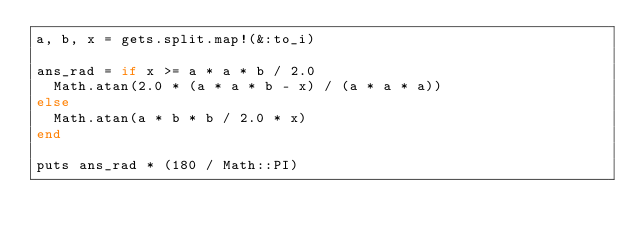<code> <loc_0><loc_0><loc_500><loc_500><_Ruby_>a, b, x = gets.split.map!(&:to_i)

ans_rad = if x >= a * a * b / 2.0
  Math.atan(2.0 * (a * a * b - x) / (a * a * a))
else
  Math.atan(a * b * b / 2.0 * x)
end

puts ans_rad * (180 / Math::PI)
</code> 